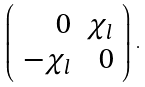<formula> <loc_0><loc_0><loc_500><loc_500>\left ( \begin{array} { r r } 0 & \chi _ { l } \\ - \chi _ { l } & 0 \end{array} \right ) \, .</formula> 